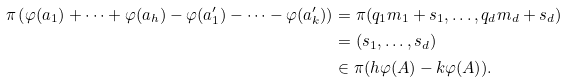<formula> <loc_0><loc_0><loc_500><loc_500>\pi \left ( \varphi ( a _ { 1 } ) + \cdots + \varphi ( a _ { h } ) - \varphi ( a ^ { \prime } _ { 1 } ) - \cdots - \varphi ( a ^ { \prime } _ { k } ) \right ) & = \pi ( q _ { 1 } m _ { 1 } + s _ { 1 } , \dots , q _ { d } m _ { d } + s _ { d } ) \\ & = ( s _ { 1 } , \dots , s _ { d } ) \\ & \in \pi ( h \varphi ( A ) - k \varphi ( A ) ) .</formula> 